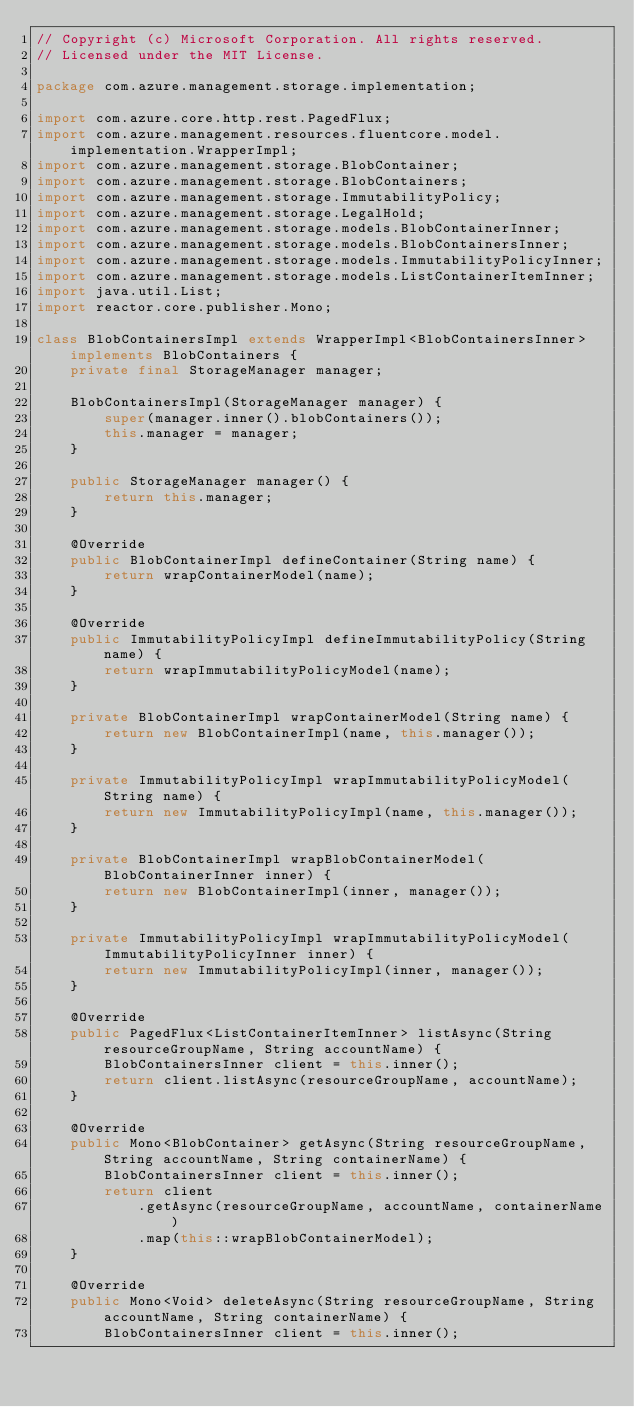<code> <loc_0><loc_0><loc_500><loc_500><_Java_>// Copyright (c) Microsoft Corporation. All rights reserved.
// Licensed under the MIT License.

package com.azure.management.storage.implementation;

import com.azure.core.http.rest.PagedFlux;
import com.azure.management.resources.fluentcore.model.implementation.WrapperImpl;
import com.azure.management.storage.BlobContainer;
import com.azure.management.storage.BlobContainers;
import com.azure.management.storage.ImmutabilityPolicy;
import com.azure.management.storage.LegalHold;
import com.azure.management.storage.models.BlobContainerInner;
import com.azure.management.storage.models.BlobContainersInner;
import com.azure.management.storage.models.ImmutabilityPolicyInner;
import com.azure.management.storage.models.ListContainerItemInner;
import java.util.List;
import reactor.core.publisher.Mono;

class BlobContainersImpl extends WrapperImpl<BlobContainersInner> implements BlobContainers {
    private final StorageManager manager;

    BlobContainersImpl(StorageManager manager) {
        super(manager.inner().blobContainers());
        this.manager = manager;
    }

    public StorageManager manager() {
        return this.manager;
    }

    @Override
    public BlobContainerImpl defineContainer(String name) {
        return wrapContainerModel(name);
    }

    @Override
    public ImmutabilityPolicyImpl defineImmutabilityPolicy(String name) {
        return wrapImmutabilityPolicyModel(name);
    }

    private BlobContainerImpl wrapContainerModel(String name) {
        return new BlobContainerImpl(name, this.manager());
    }

    private ImmutabilityPolicyImpl wrapImmutabilityPolicyModel(String name) {
        return new ImmutabilityPolicyImpl(name, this.manager());
    }

    private BlobContainerImpl wrapBlobContainerModel(BlobContainerInner inner) {
        return new BlobContainerImpl(inner, manager());
    }

    private ImmutabilityPolicyImpl wrapImmutabilityPolicyModel(ImmutabilityPolicyInner inner) {
        return new ImmutabilityPolicyImpl(inner, manager());
    }

    @Override
    public PagedFlux<ListContainerItemInner> listAsync(String resourceGroupName, String accountName) {
        BlobContainersInner client = this.inner();
        return client.listAsync(resourceGroupName, accountName);
    }

    @Override
    public Mono<BlobContainer> getAsync(String resourceGroupName, String accountName, String containerName) {
        BlobContainersInner client = this.inner();
        return client
            .getAsync(resourceGroupName, accountName, containerName)
            .map(this::wrapBlobContainerModel);
    }

    @Override
    public Mono<Void> deleteAsync(String resourceGroupName, String accountName, String containerName) {
        BlobContainersInner client = this.inner();</code> 